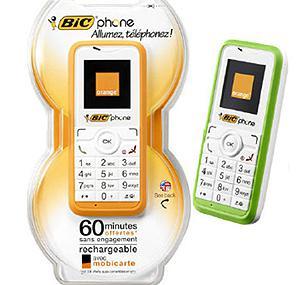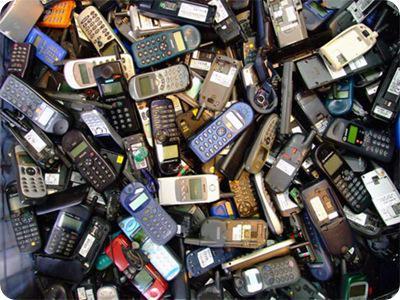The first image is the image on the left, the second image is the image on the right. For the images displayed, is the sentence "In at least one image there is no more than three standing phones that have at least thirteen buttons." factually correct? Answer yes or no. Yes. The first image is the image on the left, the second image is the image on the right. For the images shown, is this caption "The left image contains no more than two phones, and the right image shows a messy pile of at least a dozen phones." true? Answer yes or no. Yes. 